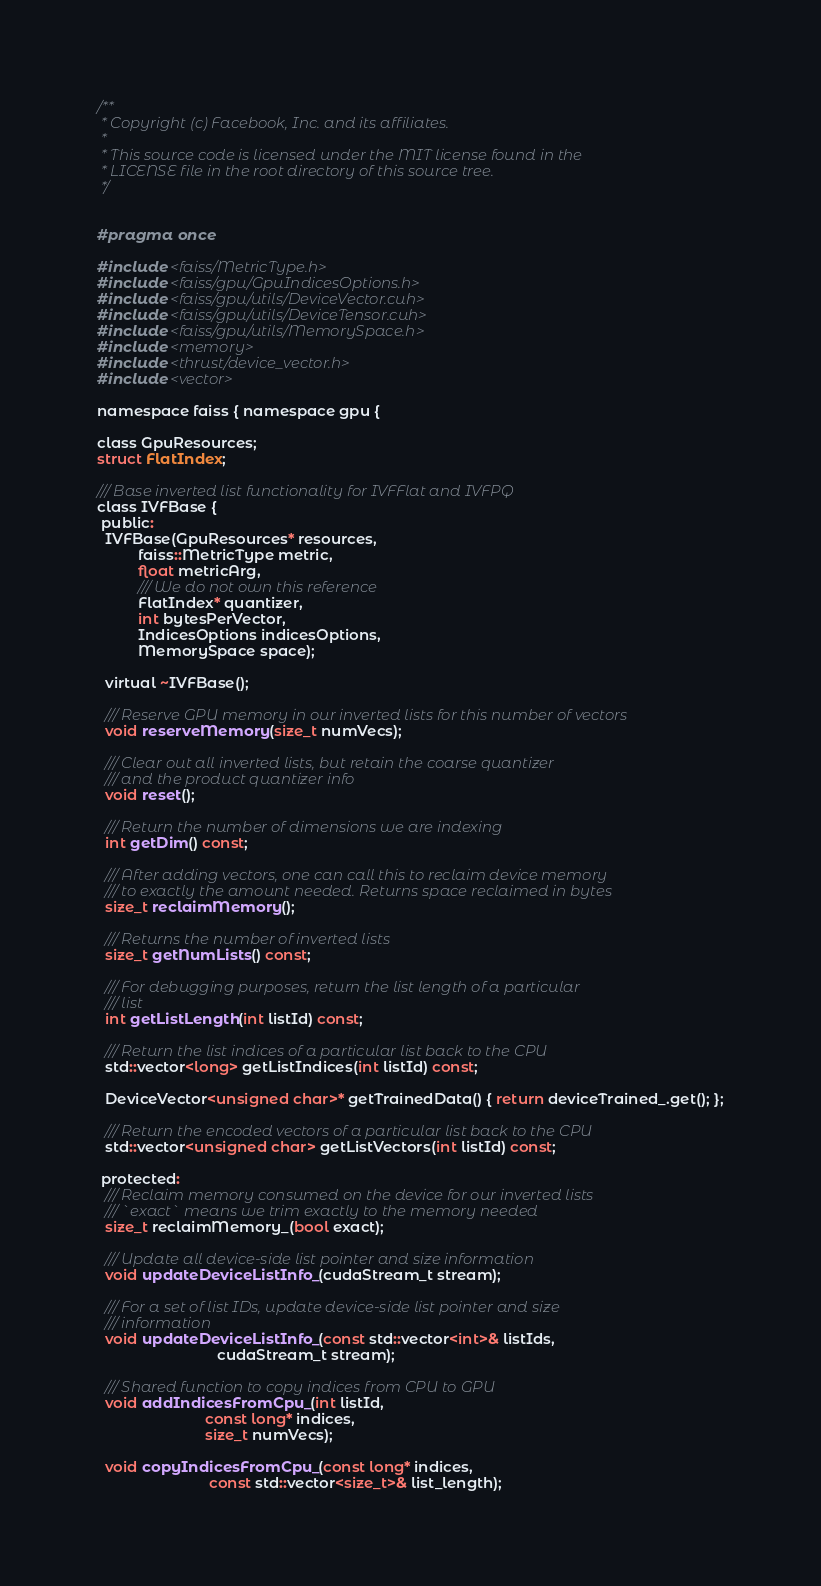<code> <loc_0><loc_0><loc_500><loc_500><_Cuda_>/**
 * Copyright (c) Facebook, Inc. and its affiliates.
 *
 * This source code is licensed under the MIT license found in the
 * LICENSE file in the root directory of this source tree.
 */


#pragma once

#include <faiss/MetricType.h>
#include <faiss/gpu/GpuIndicesOptions.h>
#include <faiss/gpu/utils/DeviceVector.cuh>
#include <faiss/gpu/utils/DeviceTensor.cuh>
#include <faiss/gpu/utils/MemorySpace.h>
#include <memory>
#include <thrust/device_vector.h>
#include <vector>

namespace faiss { namespace gpu {

class GpuResources;
struct FlatIndex;

/// Base inverted list functionality for IVFFlat and IVFPQ
class IVFBase {
 public:
  IVFBase(GpuResources* resources,
          faiss::MetricType metric,
          float metricArg,
          /// We do not own this reference
          FlatIndex* quantizer,
          int bytesPerVector,
          IndicesOptions indicesOptions,
          MemorySpace space);

  virtual ~IVFBase();

  /// Reserve GPU memory in our inverted lists for this number of vectors
  void reserveMemory(size_t numVecs);

  /// Clear out all inverted lists, but retain the coarse quantizer
  /// and the product quantizer info
  void reset();

  /// Return the number of dimensions we are indexing
  int getDim() const;

  /// After adding vectors, one can call this to reclaim device memory
  /// to exactly the amount needed. Returns space reclaimed in bytes
  size_t reclaimMemory();

  /// Returns the number of inverted lists
  size_t getNumLists() const;

  /// For debugging purposes, return the list length of a particular
  /// list
  int getListLength(int listId) const;

  /// Return the list indices of a particular list back to the CPU
  std::vector<long> getListIndices(int listId) const;

  DeviceVector<unsigned char>* getTrainedData() { return deviceTrained_.get(); };

  /// Return the encoded vectors of a particular list back to the CPU
  std::vector<unsigned char> getListVectors(int listId) const;

 protected:
  /// Reclaim memory consumed on the device for our inverted lists
  /// `exact` means we trim exactly to the memory needed
  size_t reclaimMemory_(bool exact);

  /// Update all device-side list pointer and size information
  void updateDeviceListInfo_(cudaStream_t stream);

  /// For a set of list IDs, update device-side list pointer and size
  /// information
  void updateDeviceListInfo_(const std::vector<int>& listIds,
                             cudaStream_t stream);

  /// Shared function to copy indices from CPU to GPU
  void addIndicesFromCpu_(int listId,
                          const long* indices,
                          size_t numVecs);

  void copyIndicesFromCpu_(const long* indices,
                           const std::vector<size_t>& list_length);
</code> 